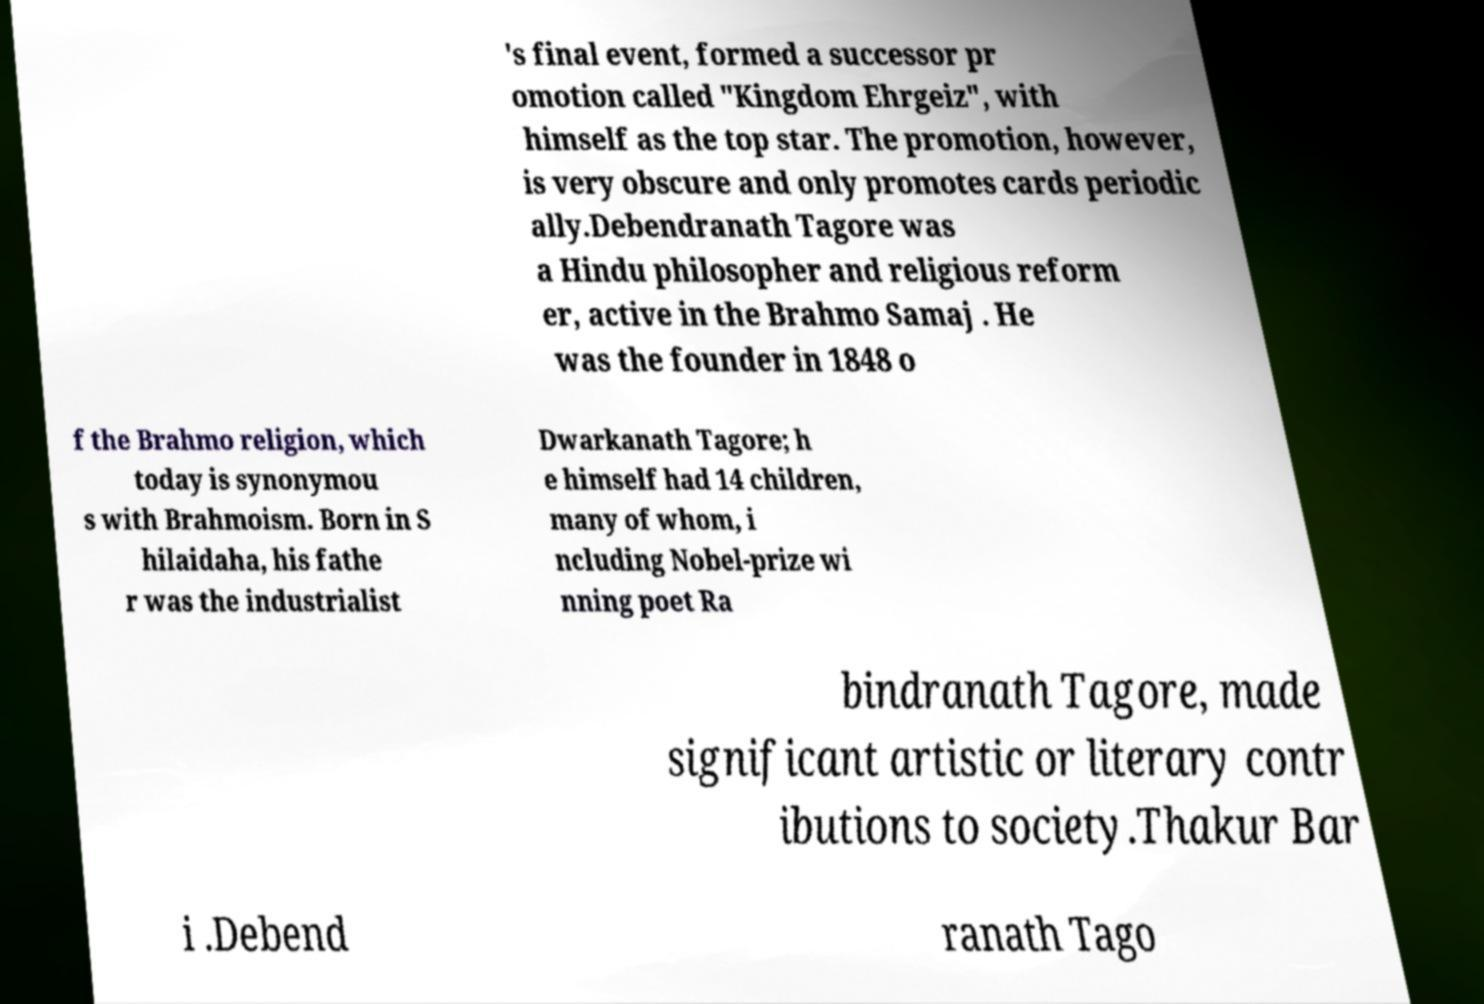Can you read and provide the text displayed in the image?This photo seems to have some interesting text. Can you extract and type it out for me? 's final event, formed a successor pr omotion called "Kingdom Ehrgeiz", with himself as the top star. The promotion, however, is very obscure and only promotes cards periodic ally.Debendranath Tagore was a Hindu philosopher and religious reform er, active in the Brahmo Samaj . He was the founder in 1848 o f the Brahmo religion, which today is synonymou s with Brahmoism. Born in S hilaidaha, his fathe r was the industrialist Dwarkanath Tagore; h e himself had 14 children, many of whom, i ncluding Nobel-prize wi nning poet Ra bindranath Tagore, made significant artistic or literary contr ibutions to society.Thakur Bar i .Debend ranath Tago 